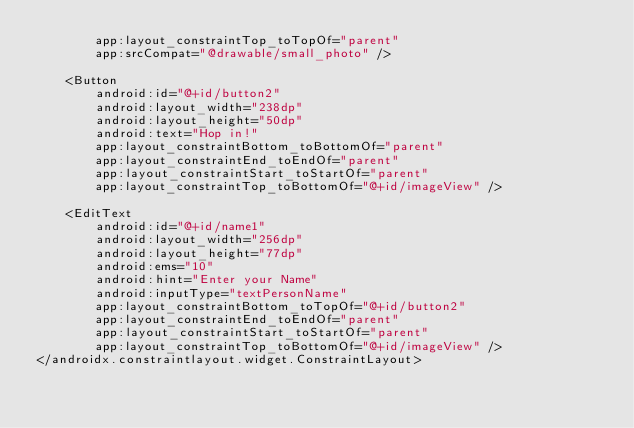<code> <loc_0><loc_0><loc_500><loc_500><_XML_>        app:layout_constraintTop_toTopOf="parent"
        app:srcCompat="@drawable/small_photo" />

    <Button
        android:id="@+id/button2"
        android:layout_width="238dp"
        android:layout_height="50dp"
        android:text="Hop in!"
        app:layout_constraintBottom_toBottomOf="parent"
        app:layout_constraintEnd_toEndOf="parent"
        app:layout_constraintStart_toStartOf="parent"
        app:layout_constraintTop_toBottomOf="@+id/imageView" />

    <EditText
        android:id="@+id/name1"
        android:layout_width="256dp"
        android:layout_height="77dp"
        android:ems="10"
        android:hint="Enter your Name"
        android:inputType="textPersonName"
        app:layout_constraintBottom_toTopOf="@+id/button2"
        app:layout_constraintEnd_toEndOf="parent"
        app:layout_constraintStart_toStartOf="parent"
        app:layout_constraintTop_toBottomOf="@+id/imageView" />
</androidx.constraintlayout.widget.ConstraintLayout></code> 